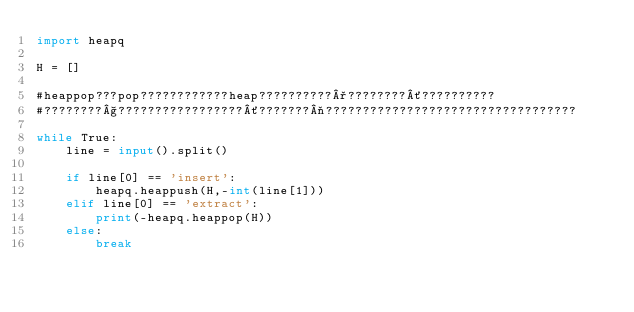Convert code to text. <code><loc_0><loc_0><loc_500><loc_500><_Python_>import heapq

H = []

#heappop???pop????????????heap??????????°????????´??????????
#????????§?????????????????´???????¬??????????????????????????????????

while True:
    line = input().split()

    if line[0] == 'insert':
        heapq.heappush(H,-int(line[1]))
    elif line[0] == 'extract':
        print(-heapq.heappop(H))
    else:
        break</code> 